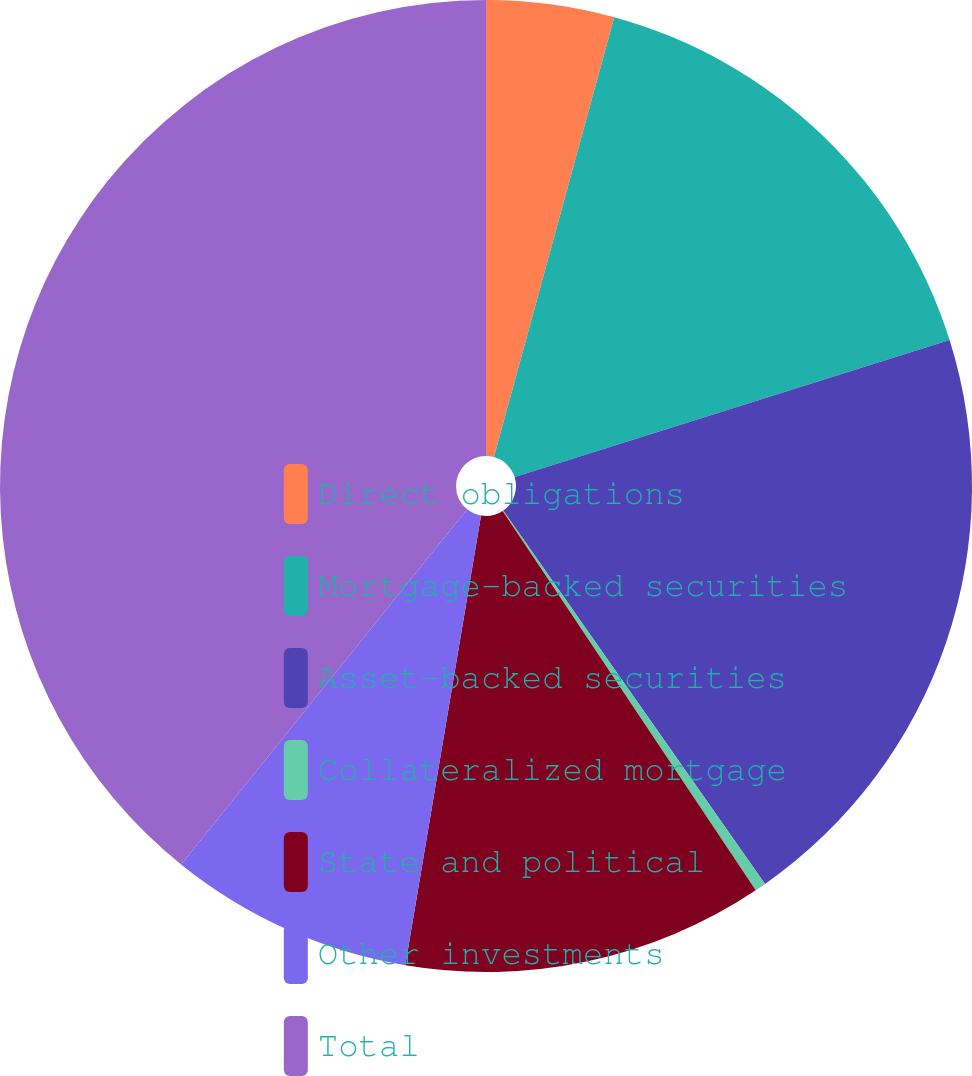Convert chart to OTSL. <chart><loc_0><loc_0><loc_500><loc_500><pie_chart><fcel>Direct obligations<fcel>Mortgage-backed securities<fcel>Asset-backed securities<fcel>Collateralized mortgage<fcel>State and political<fcel>Other investments<fcel>Total<nl><fcel>4.25%<fcel>15.9%<fcel>20.12%<fcel>0.37%<fcel>12.02%<fcel>8.14%<fcel>39.21%<nl></chart> 